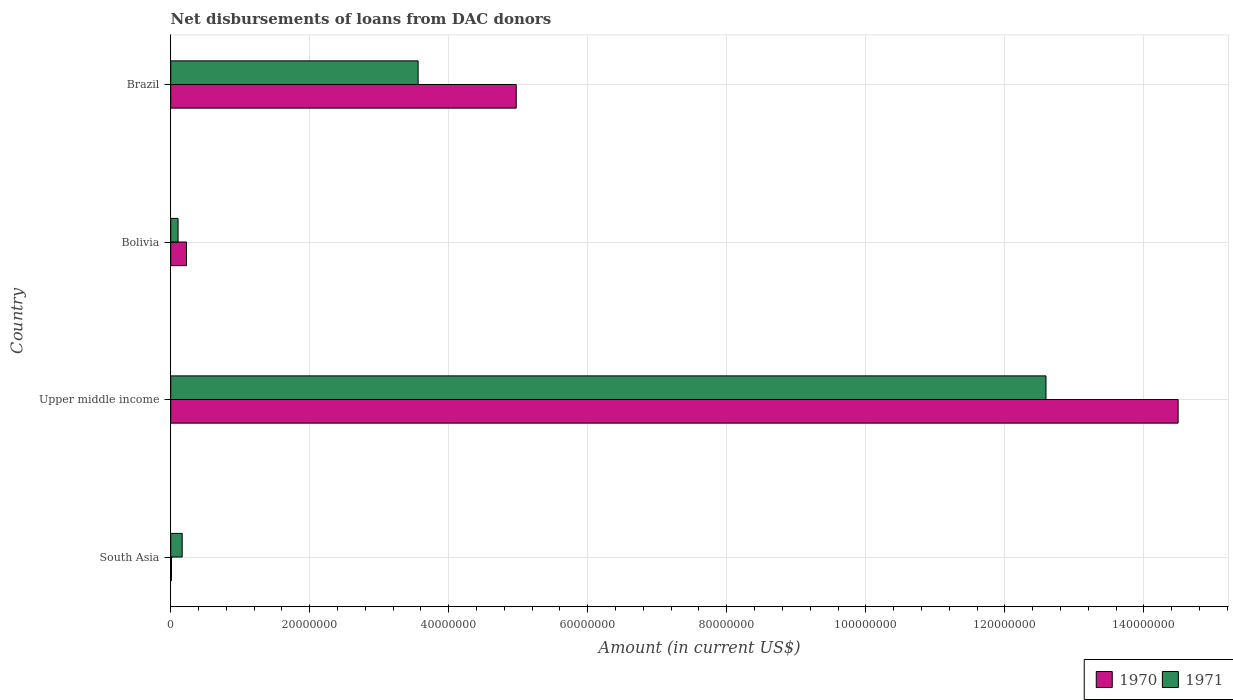How many bars are there on the 3rd tick from the top?
Your response must be concise. 2. How many bars are there on the 4th tick from the bottom?
Your answer should be compact. 2. What is the label of the 4th group of bars from the top?
Give a very brief answer. South Asia. What is the amount of loans disbursed in 1971 in South Asia?
Your answer should be compact. 1.65e+06. Across all countries, what is the maximum amount of loans disbursed in 1971?
Your answer should be very brief. 1.26e+08. Across all countries, what is the minimum amount of loans disbursed in 1970?
Make the answer very short. 1.09e+05. In which country was the amount of loans disbursed in 1971 maximum?
Your answer should be very brief. Upper middle income. What is the total amount of loans disbursed in 1971 in the graph?
Offer a very short reply. 1.64e+08. What is the difference between the amount of loans disbursed in 1970 in Brazil and that in Upper middle income?
Your answer should be compact. -9.52e+07. What is the difference between the amount of loans disbursed in 1970 in Brazil and the amount of loans disbursed in 1971 in Upper middle income?
Your answer should be very brief. -7.62e+07. What is the average amount of loans disbursed in 1970 per country?
Provide a succinct answer. 4.93e+07. What is the difference between the amount of loans disbursed in 1970 and amount of loans disbursed in 1971 in Bolivia?
Offer a terse response. 1.21e+06. What is the ratio of the amount of loans disbursed in 1970 in Brazil to that in Upper middle income?
Provide a short and direct response. 0.34. What is the difference between the highest and the second highest amount of loans disbursed in 1970?
Provide a short and direct response. 9.52e+07. What is the difference between the highest and the lowest amount of loans disbursed in 1970?
Make the answer very short. 1.45e+08. What does the 1st bar from the top in Upper middle income represents?
Provide a succinct answer. 1971. How many bars are there?
Keep it short and to the point. 8. Are all the bars in the graph horizontal?
Offer a very short reply. Yes. What is the difference between two consecutive major ticks on the X-axis?
Offer a very short reply. 2.00e+07. Are the values on the major ticks of X-axis written in scientific E-notation?
Ensure brevity in your answer.  No. Where does the legend appear in the graph?
Your response must be concise. Bottom right. How many legend labels are there?
Keep it short and to the point. 2. How are the legend labels stacked?
Make the answer very short. Horizontal. What is the title of the graph?
Keep it short and to the point. Net disbursements of loans from DAC donors. Does "2001" appear as one of the legend labels in the graph?
Your answer should be very brief. No. What is the label or title of the X-axis?
Your answer should be compact. Amount (in current US$). What is the Amount (in current US$) in 1970 in South Asia?
Ensure brevity in your answer.  1.09e+05. What is the Amount (in current US$) of 1971 in South Asia?
Offer a terse response. 1.65e+06. What is the Amount (in current US$) of 1970 in Upper middle income?
Offer a terse response. 1.45e+08. What is the Amount (in current US$) of 1971 in Upper middle income?
Offer a terse response. 1.26e+08. What is the Amount (in current US$) of 1970 in Bolivia?
Give a very brief answer. 2.27e+06. What is the Amount (in current US$) in 1971 in Bolivia?
Your response must be concise. 1.06e+06. What is the Amount (in current US$) in 1970 in Brazil?
Provide a short and direct response. 4.97e+07. What is the Amount (in current US$) of 1971 in Brazil?
Keep it short and to the point. 3.56e+07. Across all countries, what is the maximum Amount (in current US$) in 1970?
Provide a succinct answer. 1.45e+08. Across all countries, what is the maximum Amount (in current US$) in 1971?
Offer a very short reply. 1.26e+08. Across all countries, what is the minimum Amount (in current US$) in 1970?
Give a very brief answer. 1.09e+05. Across all countries, what is the minimum Amount (in current US$) in 1971?
Offer a terse response. 1.06e+06. What is the total Amount (in current US$) in 1970 in the graph?
Offer a very short reply. 1.97e+08. What is the total Amount (in current US$) of 1971 in the graph?
Offer a terse response. 1.64e+08. What is the difference between the Amount (in current US$) in 1970 in South Asia and that in Upper middle income?
Provide a succinct answer. -1.45e+08. What is the difference between the Amount (in current US$) in 1971 in South Asia and that in Upper middle income?
Ensure brevity in your answer.  -1.24e+08. What is the difference between the Amount (in current US$) of 1970 in South Asia and that in Bolivia?
Offer a very short reply. -2.16e+06. What is the difference between the Amount (in current US$) of 1971 in South Asia and that in Bolivia?
Keep it short and to the point. 5.92e+05. What is the difference between the Amount (in current US$) in 1970 in South Asia and that in Brazil?
Offer a very short reply. -4.96e+07. What is the difference between the Amount (in current US$) of 1971 in South Asia and that in Brazil?
Ensure brevity in your answer.  -3.39e+07. What is the difference between the Amount (in current US$) in 1970 in Upper middle income and that in Bolivia?
Provide a short and direct response. 1.43e+08. What is the difference between the Amount (in current US$) in 1971 in Upper middle income and that in Bolivia?
Keep it short and to the point. 1.25e+08. What is the difference between the Amount (in current US$) of 1970 in Upper middle income and that in Brazil?
Offer a terse response. 9.52e+07. What is the difference between the Amount (in current US$) in 1971 in Upper middle income and that in Brazil?
Your answer should be compact. 9.03e+07. What is the difference between the Amount (in current US$) of 1970 in Bolivia and that in Brazil?
Make the answer very short. -4.74e+07. What is the difference between the Amount (in current US$) in 1971 in Bolivia and that in Brazil?
Your answer should be very brief. -3.45e+07. What is the difference between the Amount (in current US$) in 1970 in South Asia and the Amount (in current US$) in 1971 in Upper middle income?
Give a very brief answer. -1.26e+08. What is the difference between the Amount (in current US$) of 1970 in South Asia and the Amount (in current US$) of 1971 in Bolivia?
Ensure brevity in your answer.  -9.49e+05. What is the difference between the Amount (in current US$) of 1970 in South Asia and the Amount (in current US$) of 1971 in Brazil?
Your answer should be compact. -3.55e+07. What is the difference between the Amount (in current US$) of 1970 in Upper middle income and the Amount (in current US$) of 1971 in Bolivia?
Keep it short and to the point. 1.44e+08. What is the difference between the Amount (in current US$) in 1970 in Upper middle income and the Amount (in current US$) in 1971 in Brazil?
Make the answer very short. 1.09e+08. What is the difference between the Amount (in current US$) of 1970 in Bolivia and the Amount (in current US$) of 1971 in Brazil?
Offer a terse response. -3.33e+07. What is the average Amount (in current US$) in 1970 per country?
Provide a short and direct response. 4.93e+07. What is the average Amount (in current US$) in 1971 per country?
Your response must be concise. 4.11e+07. What is the difference between the Amount (in current US$) in 1970 and Amount (in current US$) in 1971 in South Asia?
Offer a terse response. -1.54e+06. What is the difference between the Amount (in current US$) in 1970 and Amount (in current US$) in 1971 in Upper middle income?
Give a very brief answer. 1.90e+07. What is the difference between the Amount (in current US$) of 1970 and Amount (in current US$) of 1971 in Bolivia?
Give a very brief answer. 1.21e+06. What is the difference between the Amount (in current US$) in 1970 and Amount (in current US$) in 1971 in Brazil?
Your answer should be compact. 1.41e+07. What is the ratio of the Amount (in current US$) in 1970 in South Asia to that in Upper middle income?
Give a very brief answer. 0. What is the ratio of the Amount (in current US$) in 1971 in South Asia to that in Upper middle income?
Make the answer very short. 0.01. What is the ratio of the Amount (in current US$) of 1970 in South Asia to that in Bolivia?
Offer a very short reply. 0.05. What is the ratio of the Amount (in current US$) of 1971 in South Asia to that in Bolivia?
Offer a terse response. 1.56. What is the ratio of the Amount (in current US$) in 1970 in South Asia to that in Brazil?
Ensure brevity in your answer.  0. What is the ratio of the Amount (in current US$) of 1971 in South Asia to that in Brazil?
Your answer should be compact. 0.05. What is the ratio of the Amount (in current US$) of 1970 in Upper middle income to that in Bolivia?
Offer a very short reply. 63.85. What is the ratio of the Amount (in current US$) of 1971 in Upper middle income to that in Bolivia?
Give a very brief answer. 119.02. What is the ratio of the Amount (in current US$) of 1970 in Upper middle income to that in Brazil?
Make the answer very short. 2.92. What is the ratio of the Amount (in current US$) of 1971 in Upper middle income to that in Brazil?
Your answer should be compact. 3.54. What is the ratio of the Amount (in current US$) of 1970 in Bolivia to that in Brazil?
Your answer should be very brief. 0.05. What is the ratio of the Amount (in current US$) in 1971 in Bolivia to that in Brazil?
Your answer should be compact. 0.03. What is the difference between the highest and the second highest Amount (in current US$) of 1970?
Keep it short and to the point. 9.52e+07. What is the difference between the highest and the second highest Amount (in current US$) in 1971?
Keep it short and to the point. 9.03e+07. What is the difference between the highest and the lowest Amount (in current US$) in 1970?
Provide a succinct answer. 1.45e+08. What is the difference between the highest and the lowest Amount (in current US$) in 1971?
Provide a short and direct response. 1.25e+08. 